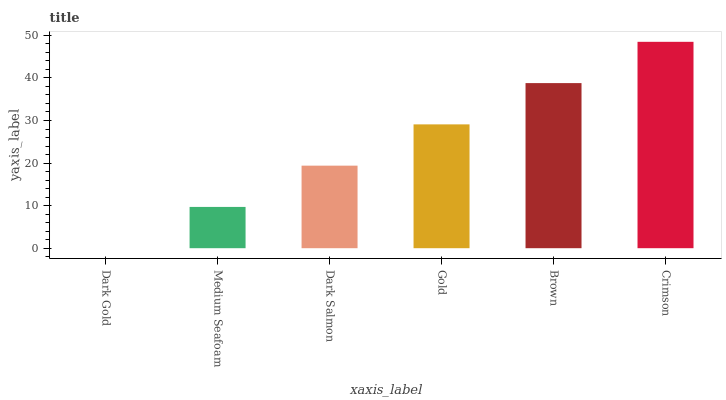Is Dark Gold the minimum?
Answer yes or no. Yes. Is Crimson the maximum?
Answer yes or no. Yes. Is Medium Seafoam the minimum?
Answer yes or no. No. Is Medium Seafoam the maximum?
Answer yes or no. No. Is Medium Seafoam greater than Dark Gold?
Answer yes or no. Yes. Is Dark Gold less than Medium Seafoam?
Answer yes or no. Yes. Is Dark Gold greater than Medium Seafoam?
Answer yes or no. No. Is Medium Seafoam less than Dark Gold?
Answer yes or no. No. Is Gold the high median?
Answer yes or no. Yes. Is Dark Salmon the low median?
Answer yes or no. Yes. Is Brown the high median?
Answer yes or no. No. Is Brown the low median?
Answer yes or no. No. 